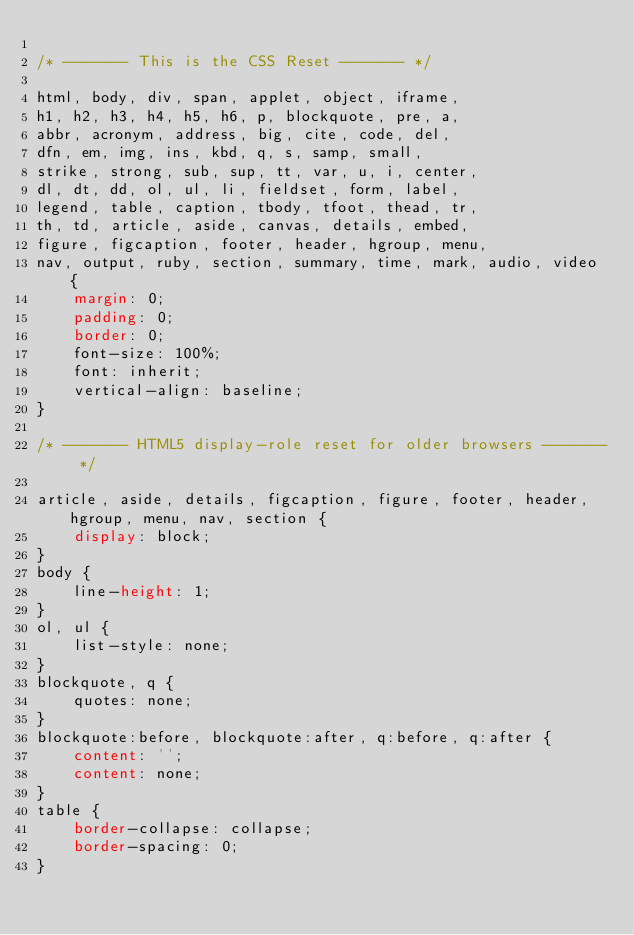Convert code to text. <code><loc_0><loc_0><loc_500><loc_500><_CSS_>
/* ------- This is the CSS Reset ------- */

html, body, div, span, applet, object, iframe,
h1, h2, h3, h4, h5, h6, p, blockquote, pre, a, 
abbr, acronym, address, big, cite, code, del,
dfn, em, img, ins, kbd, q, s, samp, small,
strike, strong, sub, sup, tt, var, u, i, center,
dl, dt, dd, ol, ul, li, fieldset, form, label,
legend, table, caption, tbody, tfoot, thead, tr,
th, td, article, aside, canvas, details, embed,
figure, figcaption, footer, header, hgroup, menu,
nav, output, ruby, section, summary, time, mark, audio, video {
	margin: 0;
	padding: 0;
	border: 0;
	font-size: 100%;
	font: inherit;
	vertical-align: baseline;
}

/* ------- HTML5 display-role reset for older browsers ------- */

article, aside, details, figcaption, figure, footer, header, hgroup, menu, nav, section {
	display: block;
}
body {
	line-height: 1;
}
ol, ul {
	list-style: none;
}
blockquote, q {
	quotes: none;
}
blockquote:before, blockquote:after, q:before, q:after {
	content: '';
	content: none;
}
table {
	border-collapse: collapse;
	border-spacing: 0;
}

</code> 